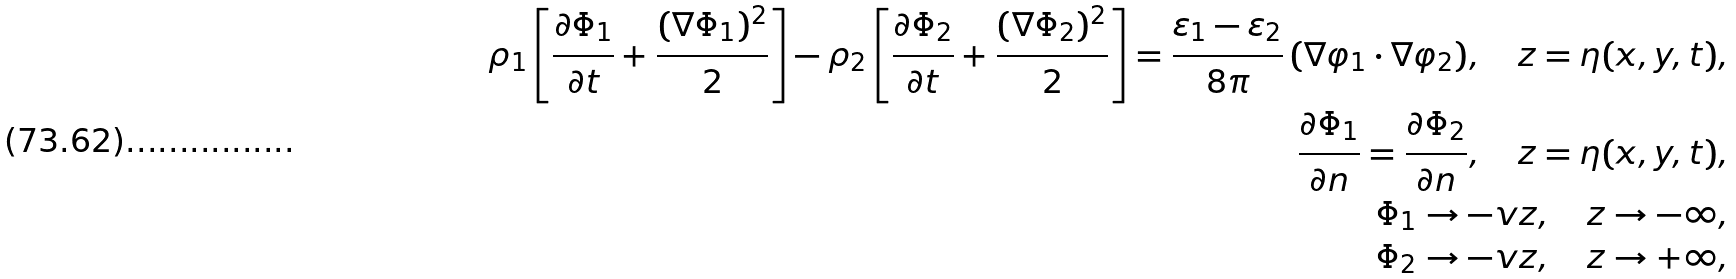<formula> <loc_0><loc_0><loc_500><loc_500>\rho _ { 1 } \left [ \frac { \partial \Phi _ { 1 } } { \partial t } + \frac { ( \nabla \Phi _ { 1 } ) ^ { 2 } } { 2 } \right ] - \rho _ { 2 } \left [ \frac { \partial \Phi _ { 2 } } { \partial t } + \frac { ( \nabla \Phi _ { 2 } ) ^ { 2 } } { 2 } \right ] = \frac { \varepsilon _ { 1 } - \varepsilon _ { 2 } } { 8 \pi } \, ( \nabla \varphi _ { 1 } \cdot \nabla \varphi _ { 2 } ) , \quad z = \eta ( x , y , t ) , \\ \frac { \partial \Phi _ { 1 } } { \partial n } = \frac { \partial \Phi _ { 2 } } { \partial n } , \quad z = \eta ( x , y , t ) , \\ \Phi _ { 1 } \to - v z , \quad z \to - \infty , \\ \Phi _ { 2 } \to - v z , \quad z \to + \infty ,</formula> 